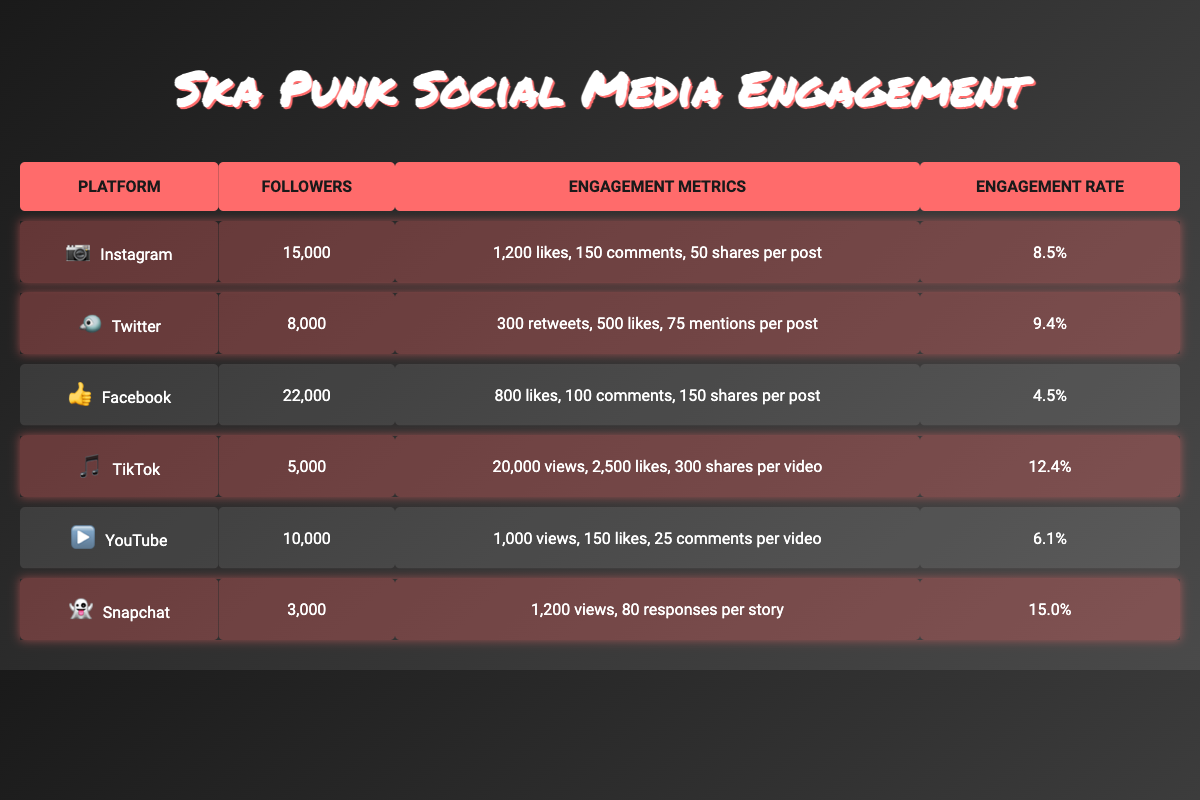What's the engagement rate on Snapchat? The engagement rate for Snapchat in the table is listed as 15.0%.
Answer: 15.0% How many followers does TikTok have? The table shows that TikTok has 5,000 followers.
Answer: 5,000 Which platform has the highest engagement rate? Comparing the engagement rates from the table, TikTok has the highest engagement rate at 12.4%.
Answer: TikTok What is the combined number of followers for Instagram and Twitter? Adding the followers for both platforms: Instagram (15,000) + Twitter (8,000) equals 23,000.
Answer: 23,000 Does Facebook have more or fewer followers than Instagram? Facebook has 22,000 followers while Instagram has 15,000, so Facebook has more followers.
Answer: More What is the average likes per post for Instagram and Facebook? For Instagram, there are 1,200 likes per post and for Facebook, 800 likes per post. The average is (1,200 + 800) / 2 = 1,000.
Answer: 1,000 Which platform has the most shares per post? The table lists 150 shares per post for Facebook, which is the highest among all platforms.
Answer: Facebook What is the difference in engagement rates between Snapchat and TikTok? Snapchat's engagement rate is 15.0% and TikTok's is 12.4%. The difference is 15.0% - 12.4% = 2.6%.
Answer: 2.6% How many total views can TikTok generate based on views per video if they posted only one video? TikTok has 20,000 views per video, which is the total views from one video.
Answer: 20,000 Out of the highlighted platforms, which one has the lowest number of followers? The highlighted platforms are Instagram, Twitter, TikTok, and Snapchat. Snapchat has the lowest at 3,000 followers.
Answer: Snapchat 